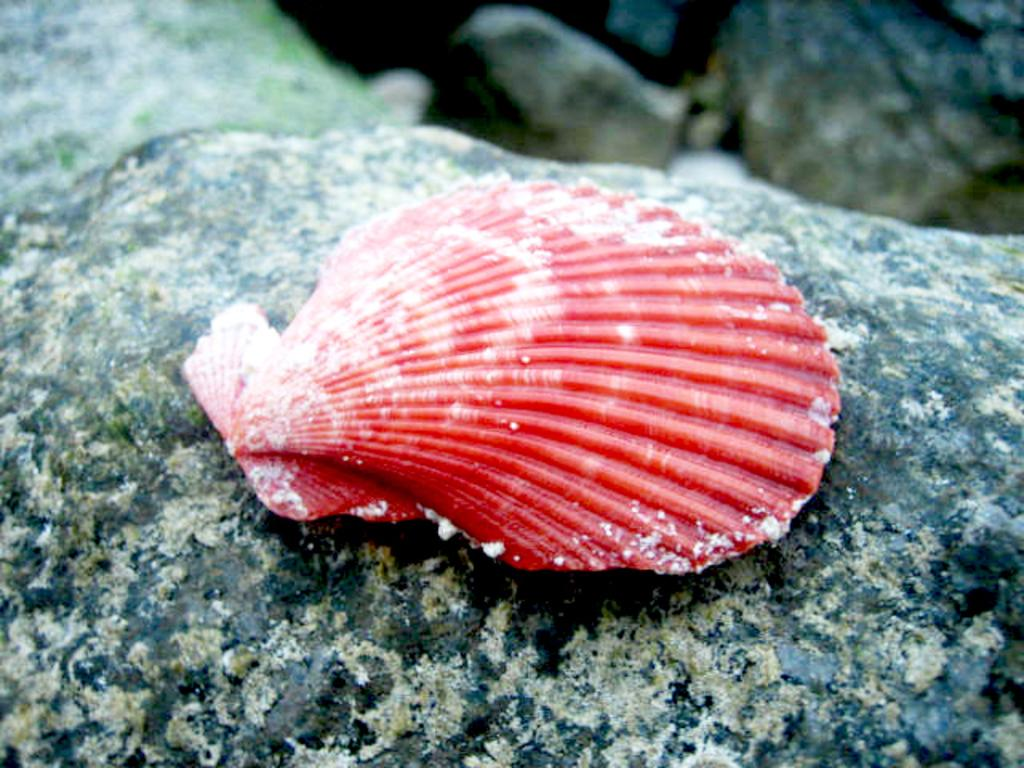What is the main object in the image? There is a shell in the image. Where is the shell located? The shell is on a rock surface. Can you describe the background of the image? The background of the rock is blurred. What type of robin can be seen sitting on the shell in the image? There is no robin present in the image; it only features a shell on a rock surface. What experience can be gained from observing the shell in the image? The image is not meant to provide an experience, but rather to showcase a shell on a rock surface. 